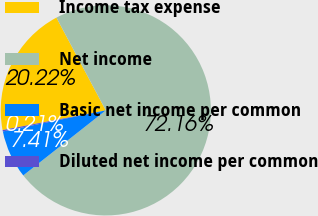Convert chart. <chart><loc_0><loc_0><loc_500><loc_500><pie_chart><fcel>Income tax expense<fcel>Net income<fcel>Basic net income per common<fcel>Diluted net income per common<nl><fcel>20.22%<fcel>72.17%<fcel>7.41%<fcel>0.21%<nl></chart> 